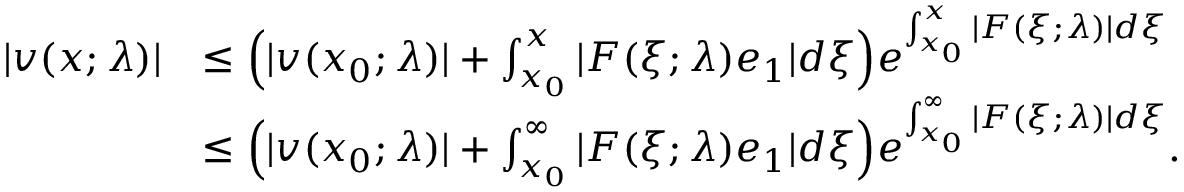<formula> <loc_0><loc_0><loc_500><loc_500>\begin{array} { r l } { | v ( x ; \lambda ) | } & { \leq \left ( | v ( x _ { 0 } ; \lambda ) | + \int _ { x _ { 0 } } ^ { x } | F ( \xi ; \lambda ) e _ { 1 } | d \xi \right ) e ^ { \int _ { x _ { 0 } } ^ { x } | F ( \xi ; \lambda ) | d \xi } } \\ & { \leq \left ( | v ( x _ { 0 } ; \lambda ) | + \int _ { x _ { 0 } } ^ { \infty } | F ( \xi ; \lambda ) e _ { 1 } | d \xi \right ) e ^ { \int _ { x _ { 0 } } ^ { \infty } | F ( \xi ; \lambda ) | d \xi } . } \end{array}</formula> 